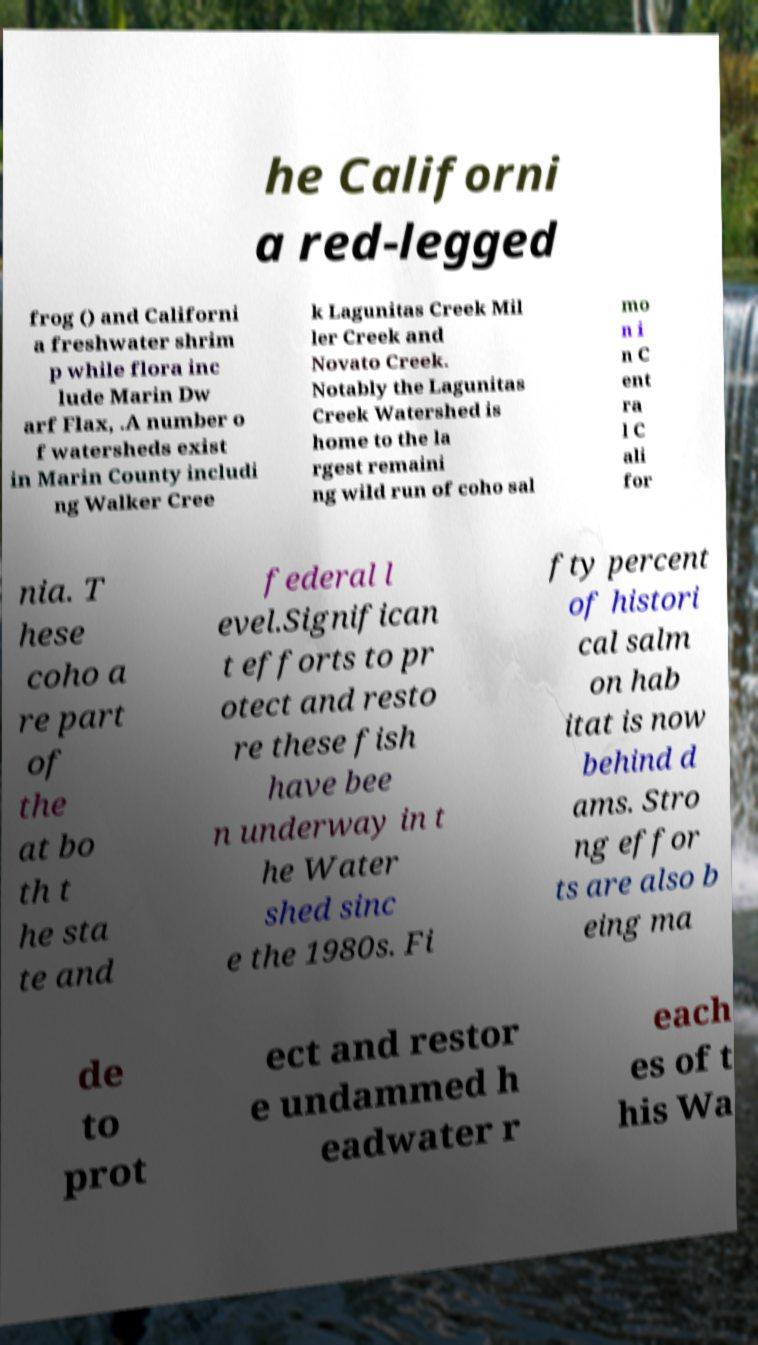Can you accurately transcribe the text from the provided image for me? he Californi a red-legged frog () and Californi a freshwater shrim p while flora inc lude Marin Dw arf Flax, .A number o f watersheds exist in Marin County includi ng Walker Cree k Lagunitas Creek Mil ler Creek and Novato Creek. Notably the Lagunitas Creek Watershed is home to the la rgest remaini ng wild run of coho sal mo n i n C ent ra l C ali for nia. T hese coho a re part of the at bo th t he sta te and federal l evel.Significan t efforts to pr otect and resto re these fish have bee n underway in t he Water shed sinc e the 1980s. Fi fty percent of histori cal salm on hab itat is now behind d ams. Stro ng effor ts are also b eing ma de to prot ect and restor e undammed h eadwater r each es of t his Wa 